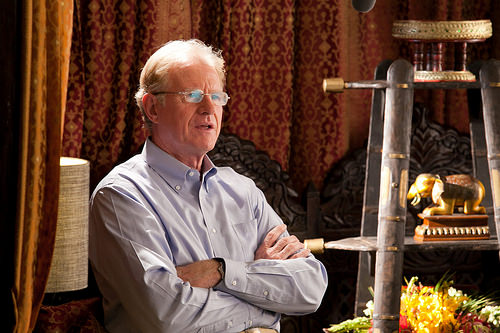<image>
Can you confirm if the elephant is behind the man? No. The elephant is not behind the man. From this viewpoint, the elephant appears to be positioned elsewhere in the scene. 